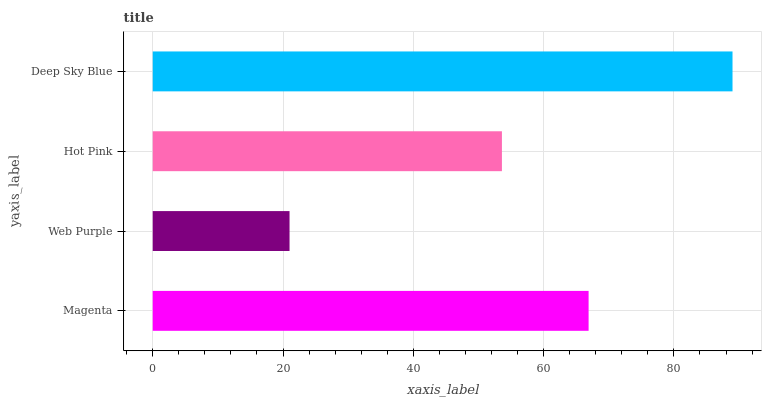Is Web Purple the minimum?
Answer yes or no. Yes. Is Deep Sky Blue the maximum?
Answer yes or no. Yes. Is Hot Pink the minimum?
Answer yes or no. No. Is Hot Pink the maximum?
Answer yes or no. No. Is Hot Pink greater than Web Purple?
Answer yes or no. Yes. Is Web Purple less than Hot Pink?
Answer yes or no. Yes. Is Web Purple greater than Hot Pink?
Answer yes or no. No. Is Hot Pink less than Web Purple?
Answer yes or no. No. Is Magenta the high median?
Answer yes or no. Yes. Is Hot Pink the low median?
Answer yes or no. Yes. Is Web Purple the high median?
Answer yes or no. No. Is Deep Sky Blue the low median?
Answer yes or no. No. 